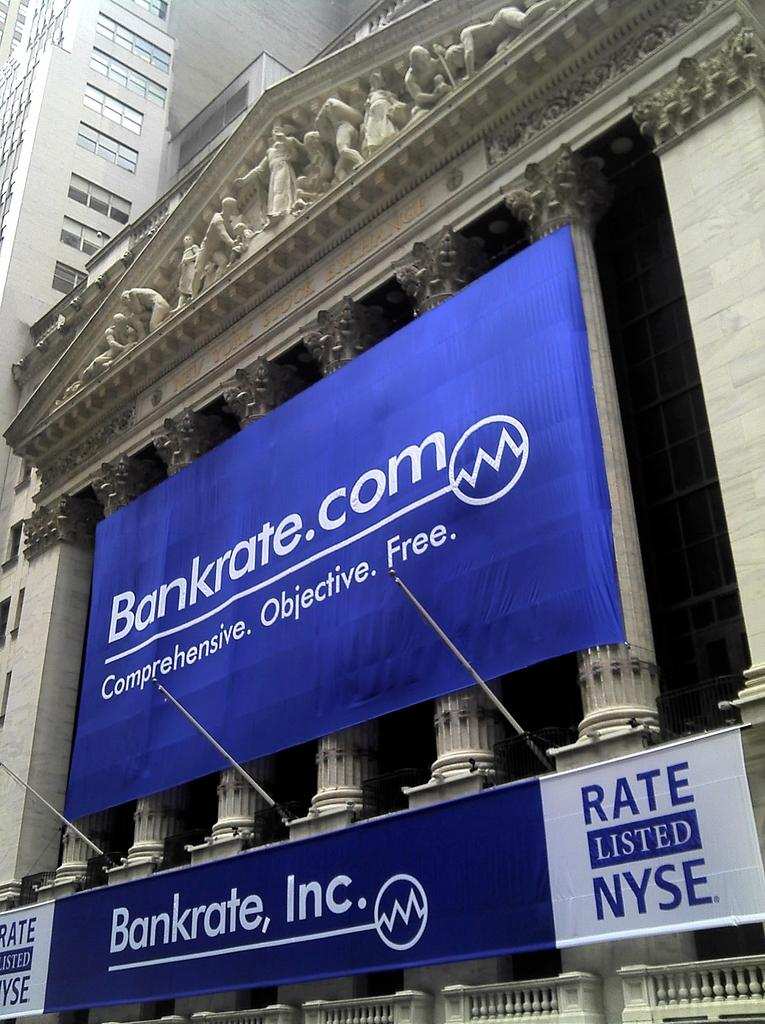What is the main subject of the image? The main subject of the image is the front view of a building. What decorative elements can be seen in the image? There are sculptures and banners in the image. What type of windows are present on the building? The building has glass windows at the top. What type of snow can be seen falling on the building in the image? There is no snow present in the image; it is not mentioned in the provided facts. 